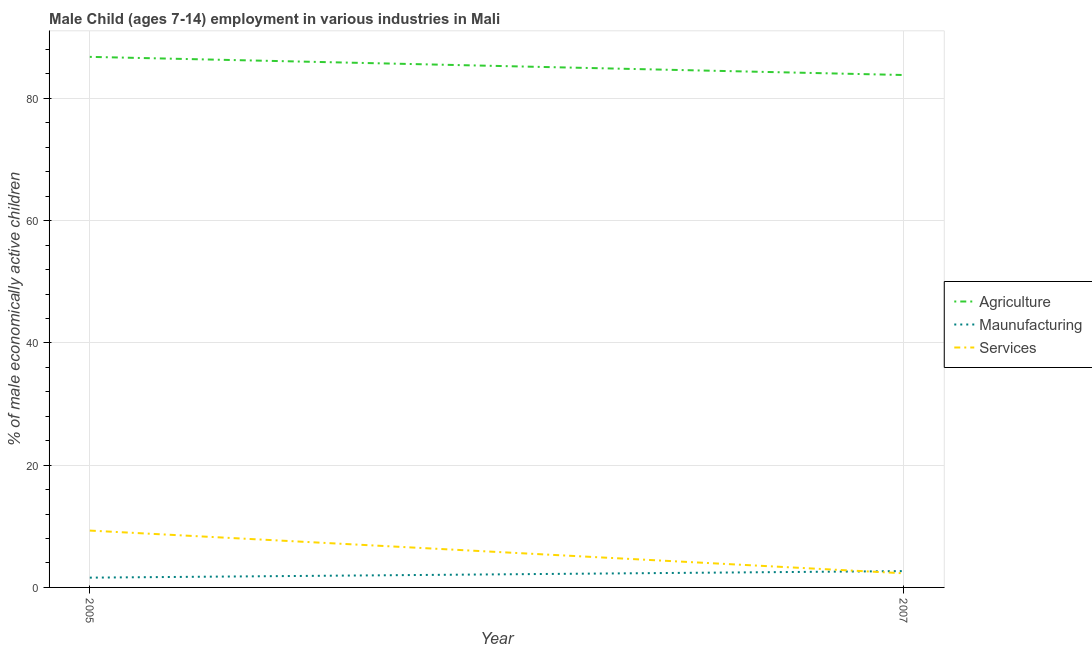Is the number of lines equal to the number of legend labels?
Make the answer very short. Yes. What is the percentage of economically active children in services in 2005?
Your answer should be compact. 9.3. Across all years, what is the maximum percentage of economically active children in agriculture?
Offer a terse response. 86.8. Across all years, what is the minimum percentage of economically active children in services?
Keep it short and to the point. 2.31. In which year was the percentage of economically active children in agriculture maximum?
Offer a terse response. 2005. What is the total percentage of economically active children in services in the graph?
Your response must be concise. 11.61. What is the difference between the percentage of economically active children in agriculture in 2005 and that in 2007?
Offer a very short reply. 2.97. What is the difference between the percentage of economically active children in agriculture in 2007 and the percentage of economically active children in manufacturing in 2005?
Your response must be concise. 82.23. What is the average percentage of economically active children in manufacturing per year?
Provide a succinct answer. 2.13. In the year 2005, what is the difference between the percentage of economically active children in manufacturing and percentage of economically active children in agriculture?
Ensure brevity in your answer.  -85.2. What is the ratio of the percentage of economically active children in agriculture in 2005 to that in 2007?
Keep it short and to the point. 1.04. In how many years, is the percentage of economically active children in manufacturing greater than the average percentage of economically active children in manufacturing taken over all years?
Provide a short and direct response. 1. Is it the case that in every year, the sum of the percentage of economically active children in agriculture and percentage of economically active children in manufacturing is greater than the percentage of economically active children in services?
Ensure brevity in your answer.  Yes. Does the percentage of economically active children in services monotonically increase over the years?
Offer a very short reply. No. Is the percentage of economically active children in services strictly less than the percentage of economically active children in agriculture over the years?
Your answer should be compact. Yes. How many lines are there?
Your answer should be very brief. 3. What is the difference between two consecutive major ticks on the Y-axis?
Provide a short and direct response. 20. Does the graph contain grids?
Your answer should be compact. Yes. How are the legend labels stacked?
Your answer should be very brief. Vertical. What is the title of the graph?
Ensure brevity in your answer.  Male Child (ages 7-14) employment in various industries in Mali. What is the label or title of the Y-axis?
Give a very brief answer. % of male economically active children. What is the % of male economically active children in Agriculture in 2005?
Offer a terse response. 86.8. What is the % of male economically active children of Services in 2005?
Ensure brevity in your answer.  9.3. What is the % of male economically active children in Agriculture in 2007?
Your answer should be compact. 83.83. What is the % of male economically active children in Maunufacturing in 2007?
Ensure brevity in your answer.  2.67. What is the % of male economically active children of Services in 2007?
Your response must be concise. 2.31. Across all years, what is the maximum % of male economically active children of Agriculture?
Your answer should be very brief. 86.8. Across all years, what is the maximum % of male economically active children in Maunufacturing?
Ensure brevity in your answer.  2.67. Across all years, what is the maximum % of male economically active children of Services?
Your response must be concise. 9.3. Across all years, what is the minimum % of male economically active children of Agriculture?
Provide a succinct answer. 83.83. Across all years, what is the minimum % of male economically active children of Maunufacturing?
Keep it short and to the point. 1.6. Across all years, what is the minimum % of male economically active children of Services?
Your response must be concise. 2.31. What is the total % of male economically active children in Agriculture in the graph?
Your answer should be very brief. 170.63. What is the total % of male economically active children in Maunufacturing in the graph?
Your response must be concise. 4.27. What is the total % of male economically active children in Services in the graph?
Provide a short and direct response. 11.61. What is the difference between the % of male economically active children of Agriculture in 2005 and that in 2007?
Offer a very short reply. 2.97. What is the difference between the % of male economically active children in Maunufacturing in 2005 and that in 2007?
Offer a very short reply. -1.07. What is the difference between the % of male economically active children of Services in 2005 and that in 2007?
Give a very brief answer. 6.99. What is the difference between the % of male economically active children in Agriculture in 2005 and the % of male economically active children in Maunufacturing in 2007?
Your answer should be compact. 84.13. What is the difference between the % of male economically active children of Agriculture in 2005 and the % of male economically active children of Services in 2007?
Provide a short and direct response. 84.49. What is the difference between the % of male economically active children of Maunufacturing in 2005 and the % of male economically active children of Services in 2007?
Your response must be concise. -0.71. What is the average % of male economically active children of Agriculture per year?
Make the answer very short. 85.31. What is the average % of male economically active children of Maunufacturing per year?
Provide a succinct answer. 2.13. What is the average % of male economically active children in Services per year?
Provide a short and direct response. 5.8. In the year 2005, what is the difference between the % of male economically active children of Agriculture and % of male economically active children of Maunufacturing?
Provide a succinct answer. 85.2. In the year 2005, what is the difference between the % of male economically active children in Agriculture and % of male economically active children in Services?
Ensure brevity in your answer.  77.5. In the year 2005, what is the difference between the % of male economically active children in Maunufacturing and % of male economically active children in Services?
Your response must be concise. -7.7. In the year 2007, what is the difference between the % of male economically active children of Agriculture and % of male economically active children of Maunufacturing?
Your response must be concise. 81.16. In the year 2007, what is the difference between the % of male economically active children of Agriculture and % of male economically active children of Services?
Give a very brief answer. 81.52. In the year 2007, what is the difference between the % of male economically active children of Maunufacturing and % of male economically active children of Services?
Provide a short and direct response. 0.36. What is the ratio of the % of male economically active children of Agriculture in 2005 to that in 2007?
Provide a succinct answer. 1.04. What is the ratio of the % of male economically active children of Maunufacturing in 2005 to that in 2007?
Your response must be concise. 0.6. What is the ratio of the % of male economically active children in Services in 2005 to that in 2007?
Your answer should be compact. 4.03. What is the difference between the highest and the second highest % of male economically active children of Agriculture?
Keep it short and to the point. 2.97. What is the difference between the highest and the second highest % of male economically active children of Maunufacturing?
Your answer should be compact. 1.07. What is the difference between the highest and the second highest % of male economically active children of Services?
Provide a short and direct response. 6.99. What is the difference between the highest and the lowest % of male economically active children of Agriculture?
Your response must be concise. 2.97. What is the difference between the highest and the lowest % of male economically active children in Maunufacturing?
Your answer should be very brief. 1.07. What is the difference between the highest and the lowest % of male economically active children of Services?
Your response must be concise. 6.99. 